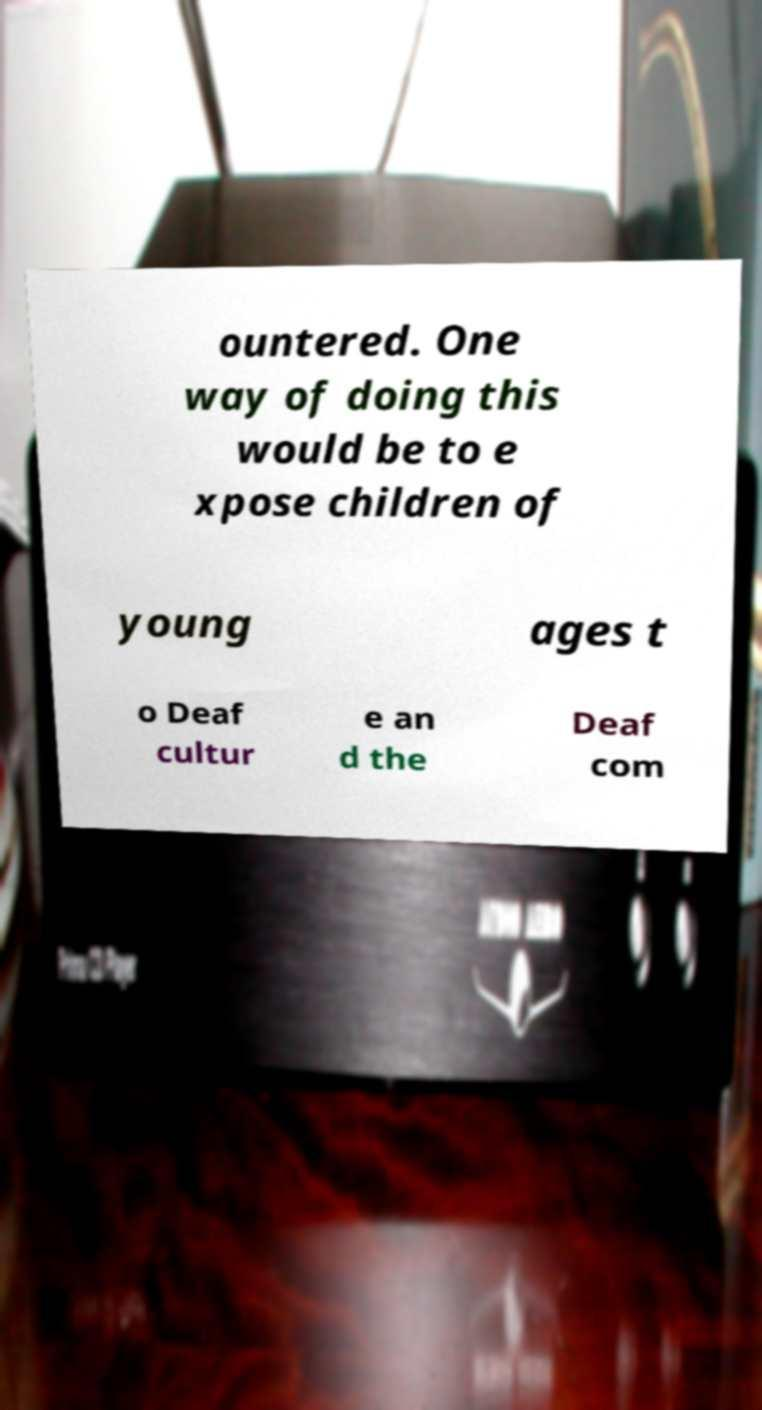There's text embedded in this image that I need extracted. Can you transcribe it verbatim? ountered. One way of doing this would be to e xpose children of young ages t o Deaf cultur e an d the Deaf com 